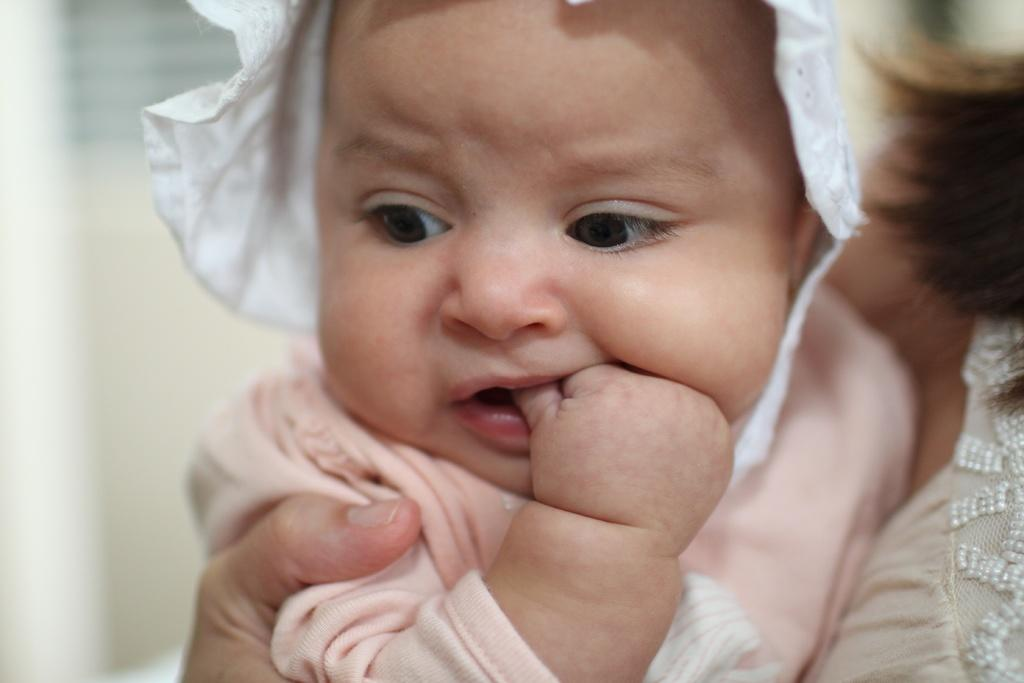What is the person in the image doing with the kid? The person is holding the kid in the image. How is the person holding the kid? The person is holding the kid with one hand. What can be seen in the background of the image? There is a wall visible in the background of the image, although it is blurry. What type of grain is being harvested by the person in the image? There is no grain or harvesting activity present in the image; it features a person holding a kid. Who is the representative of the organization in the image? There is no representative or organization mentioned in the image; it simply shows a person holding a kid. 